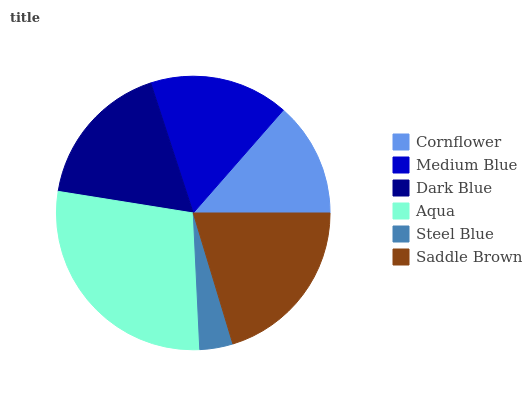Is Steel Blue the minimum?
Answer yes or no. Yes. Is Aqua the maximum?
Answer yes or no. Yes. Is Medium Blue the minimum?
Answer yes or no. No. Is Medium Blue the maximum?
Answer yes or no. No. Is Medium Blue greater than Cornflower?
Answer yes or no. Yes. Is Cornflower less than Medium Blue?
Answer yes or no. Yes. Is Cornflower greater than Medium Blue?
Answer yes or no. No. Is Medium Blue less than Cornflower?
Answer yes or no. No. Is Dark Blue the high median?
Answer yes or no. Yes. Is Medium Blue the low median?
Answer yes or no. Yes. Is Aqua the high median?
Answer yes or no. No. Is Steel Blue the low median?
Answer yes or no. No. 